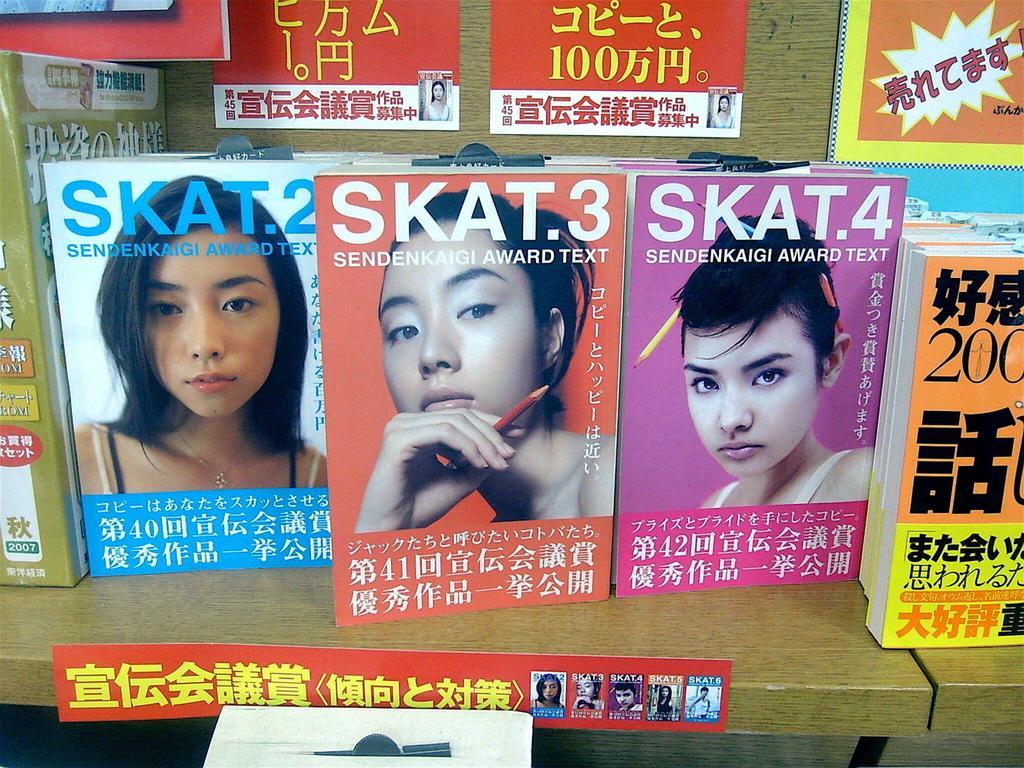Please provide a concise description of this image. In this image, we can see few books on the wooden objects. Here we can see posters. On the books, we can see images and text. 